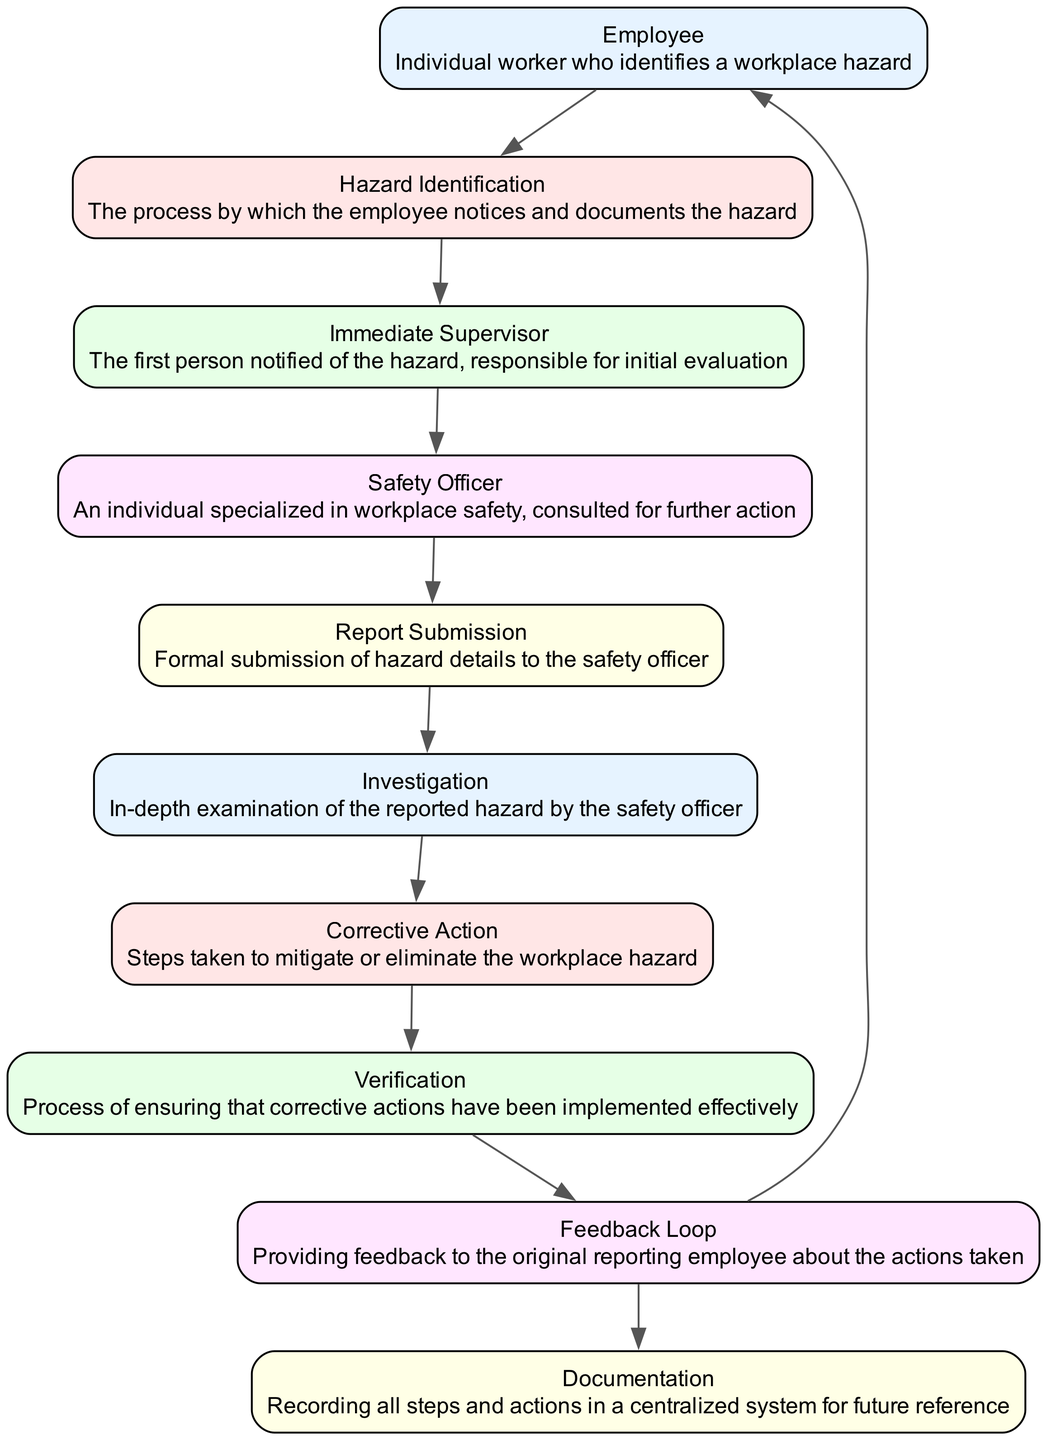What is the first step in reporting a workplace hazard? The first step in reporting a workplace hazard is performed by the Employee who identifies the hazard. This is represented by the first component in the diagram, indicating the initiation of the process.
Answer: Employee How many nodes are present in the diagram? The diagram contains 10 distinct components or nodes, as listed in the components section. Each node corresponds to a specific step in the communication flow.
Answer: 10 Which component directly follows the Immediate Supervisor? The Immediate Supervisor is followed directly by the Safety Officer in the flow of the diagram. This relationship indicates that the immediate supervisor's evaluation leads to the involvement of the safety officer.
Answer: Safety Officer What action is taken after the Investigation phase? Following the Investigation phase, the next action taken is Corrective Action, which aims to address the findings of the investigation. This step illustrates the movement from assessing to mitigating the hazard.
Answer: Corrective Action What feedback is provided to the Employee? The Employee receives feedback through the Feedback Loop, which informs them about the actions taken regarding the reported hazard. This process ensures that the original reporting employee is aware of the progress.
Answer: Feedback Loop What is the last component listed in the diagram? The last component in the diagram is Documentation, which signifies the importance of recording all steps and actions taken during the hazard reporting process for future reference. This ensures accountability and traceability.
Answer: Documentation Who is responsible for the initial evaluation of the hazard? The initial evaluation of the hazard is the responsibility of the Immediate Supervisor, who is the first point of contact in the reporting structure. This reflects a key role in assessing reported hazards.
Answer: Immediate Supervisor How many edges connect the nodes in the diagram? There are 9 edges connecting the nodes in the diagram, which represent the flow of communication between the various components involved in the hazard reporting process.
Answer: 9 What process ensures corrective actions have been implemented effectively? The process that ensures corrective actions have been implemented effectively is called Verification. This step is crucial for confirming that the measures taken have resolved the identified hazards.
Answer: Verification 